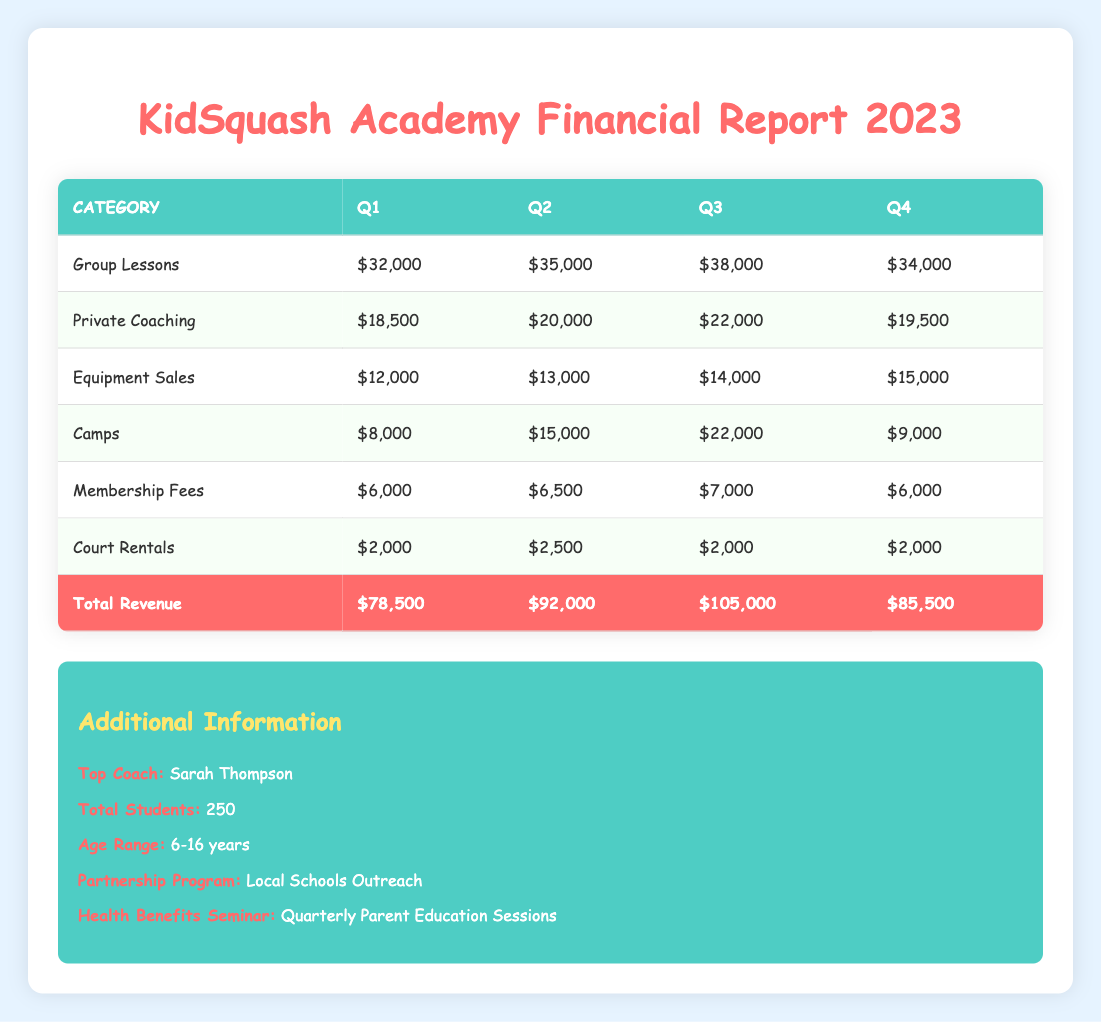What was the total revenue for Q3? The total revenue for each quarter is listed in the last row of the table. For Q3, it shows $105,000.
Answer: $105,000 How much revenue did the Group Lessons generate in Q2? By looking at the row for Group Lessons specifically in Q2, it shows that the revenue was $35,000.
Answer: $35,000 Which category had the highest revenue in Q4? To find the highest revenue category for Q4, we compare all amounts in the Q4 column. Group Lessons generated $34,000, and Summer Camps generated $9,000. Group Lessons has the highest revenue.
Answer: Group Lessons What is the total revenue generated from Private Coaching across all quarters? To get the total revenue from Private Coaching, we add the amounts from all quarters: $18,500 (Q1) + $20,000 (Q2) + $22,000 (Q3) + $19,500 (Q4) = $80,000.
Answer: $80,000 Did the total revenue increase from Q1 to Q4? The total revenue for Q1 is $78,500, and for Q4 it is $85,500. Since $85,500 is greater than $78,500, the revenue did increase.
Answer: Yes What was the average revenue from Equipment Sales across all quarters? We sum the Equipment Sales for each quarter: $12,000 (Q1) + $13,000 (Q2) + $14,000 (Q3) + $15,000 (Q4) = $54,000. There are 4 quarters, so we divide: $54,000 / 4 = $13,500.
Answer: $13,500 Which quarter had the highest total revenue and how much was it? Looking through the total revenue values for all quarters, Q3 has the highest value at $105,000, compared to Q1 ($78,500), Q2 ($92,000), and Q4 ($85,500).
Answer: Q3, $105,000 How much revenue did Court Rentals generate in Q1? The revenue for Court Rentals in Q1 is provided directly in the table, showing $2,000.
Answer: $2,000 Was the total revenue in Q2 higher than Q1 and Q4 combined? First, we calculate combined revenue for Q1 and Q4: $78,500 (Q1) + $85,500 (Q4) = $164,000. Q2 total is $92,000, which is less than $164,000. Thus, Q2 revenue is not higher than the combined total.
Answer: No 